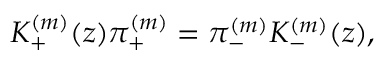<formula> <loc_0><loc_0><loc_500><loc_500>K _ { + } ^ { ( m ) } ( z ) \pi _ { + } ^ { ( m ) } = \pi _ { - } ^ { ( m ) } K _ { - } ^ { ( m ) } ( z ) ,</formula> 